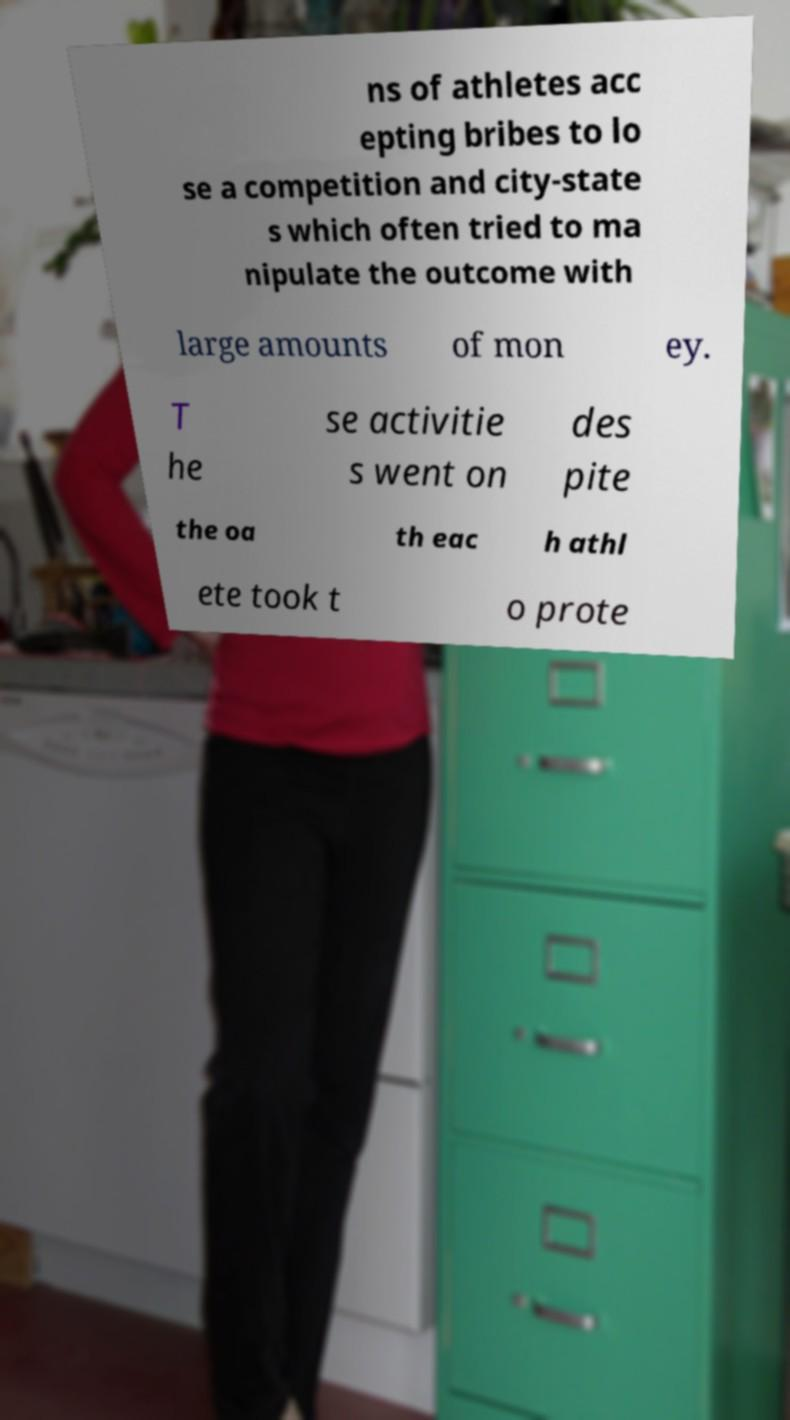What messages or text are displayed in this image? I need them in a readable, typed format. ns of athletes acc epting bribes to lo se a competition and city-state s which often tried to ma nipulate the outcome with large amounts of mon ey. T he se activitie s went on des pite the oa th eac h athl ete took t o prote 